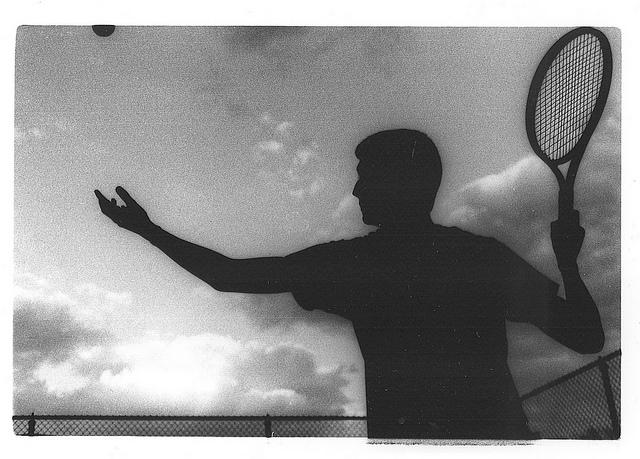Is it daytime outside?
Keep it brief. Yes. What is the man playing?
Answer briefly. Tennis. What is the man holding?
Be succinct. Tennis racket. Is there anything on his wrist?
Give a very brief answer. No. 